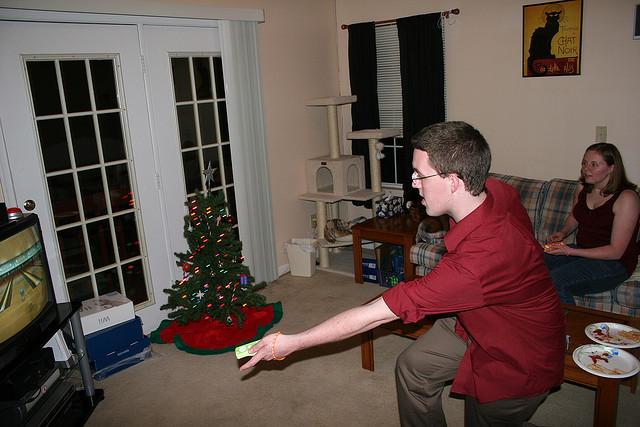Are all the plates the same color?
Answer briefly. Yes. Is the man bald?
Keep it brief. No. What is in the right corner of the photo?
Write a very short answer. Woman. Which holiday may these people have recently celebrated?
Be succinct. Christmas. Is this a private residence?
Concise answer only. Yes. What color is his shirt?
Concise answer only. Red. How many people are in the photograph behind the man?
Answer briefly. 1. What is the child sitting on?
Concise answer only. Table. What is the floor made of?
Quick response, please. Carpet. What game is the male playing?
Concise answer only. Bowling. Is the male wearing glasses?
Answer briefly. Yes. Where is the guitar?
Short answer required. Nowhere. Is the boy wearing comfortable clothing?
Keep it brief. No. What color is the women's shirt?
Keep it brief. Black. Are there balloons?
Short answer required. No. What shape is on the window of the door?
Short answer required. Rectangle. Does he have a skull on his shirt?
Be succinct. No. Who is being displayed under the Christmas tree?
Write a very short answer. No one. 